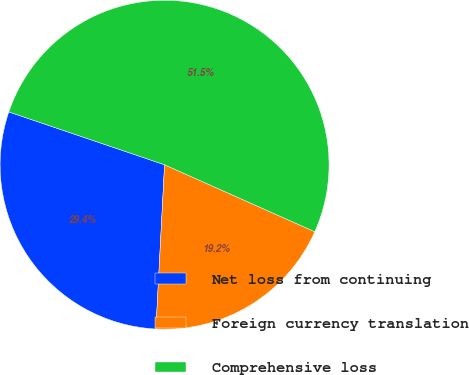Convert chart to OTSL. <chart><loc_0><loc_0><loc_500><loc_500><pie_chart><fcel>Net loss from continuing<fcel>Foreign currency translation<fcel>Comprehensive loss<nl><fcel>29.37%<fcel>19.16%<fcel>51.47%<nl></chart> 